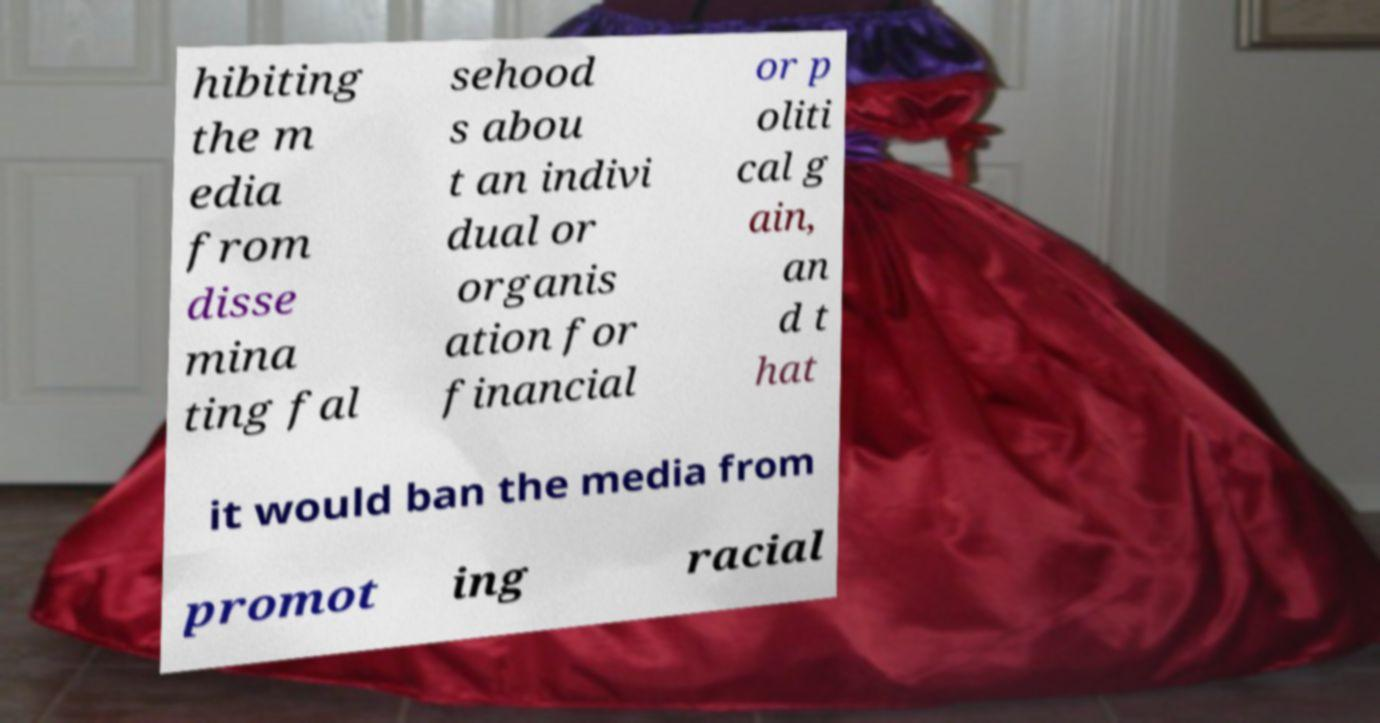Could you assist in decoding the text presented in this image and type it out clearly? hibiting the m edia from disse mina ting fal sehood s abou t an indivi dual or organis ation for financial or p oliti cal g ain, an d t hat it would ban the media from promot ing racial 